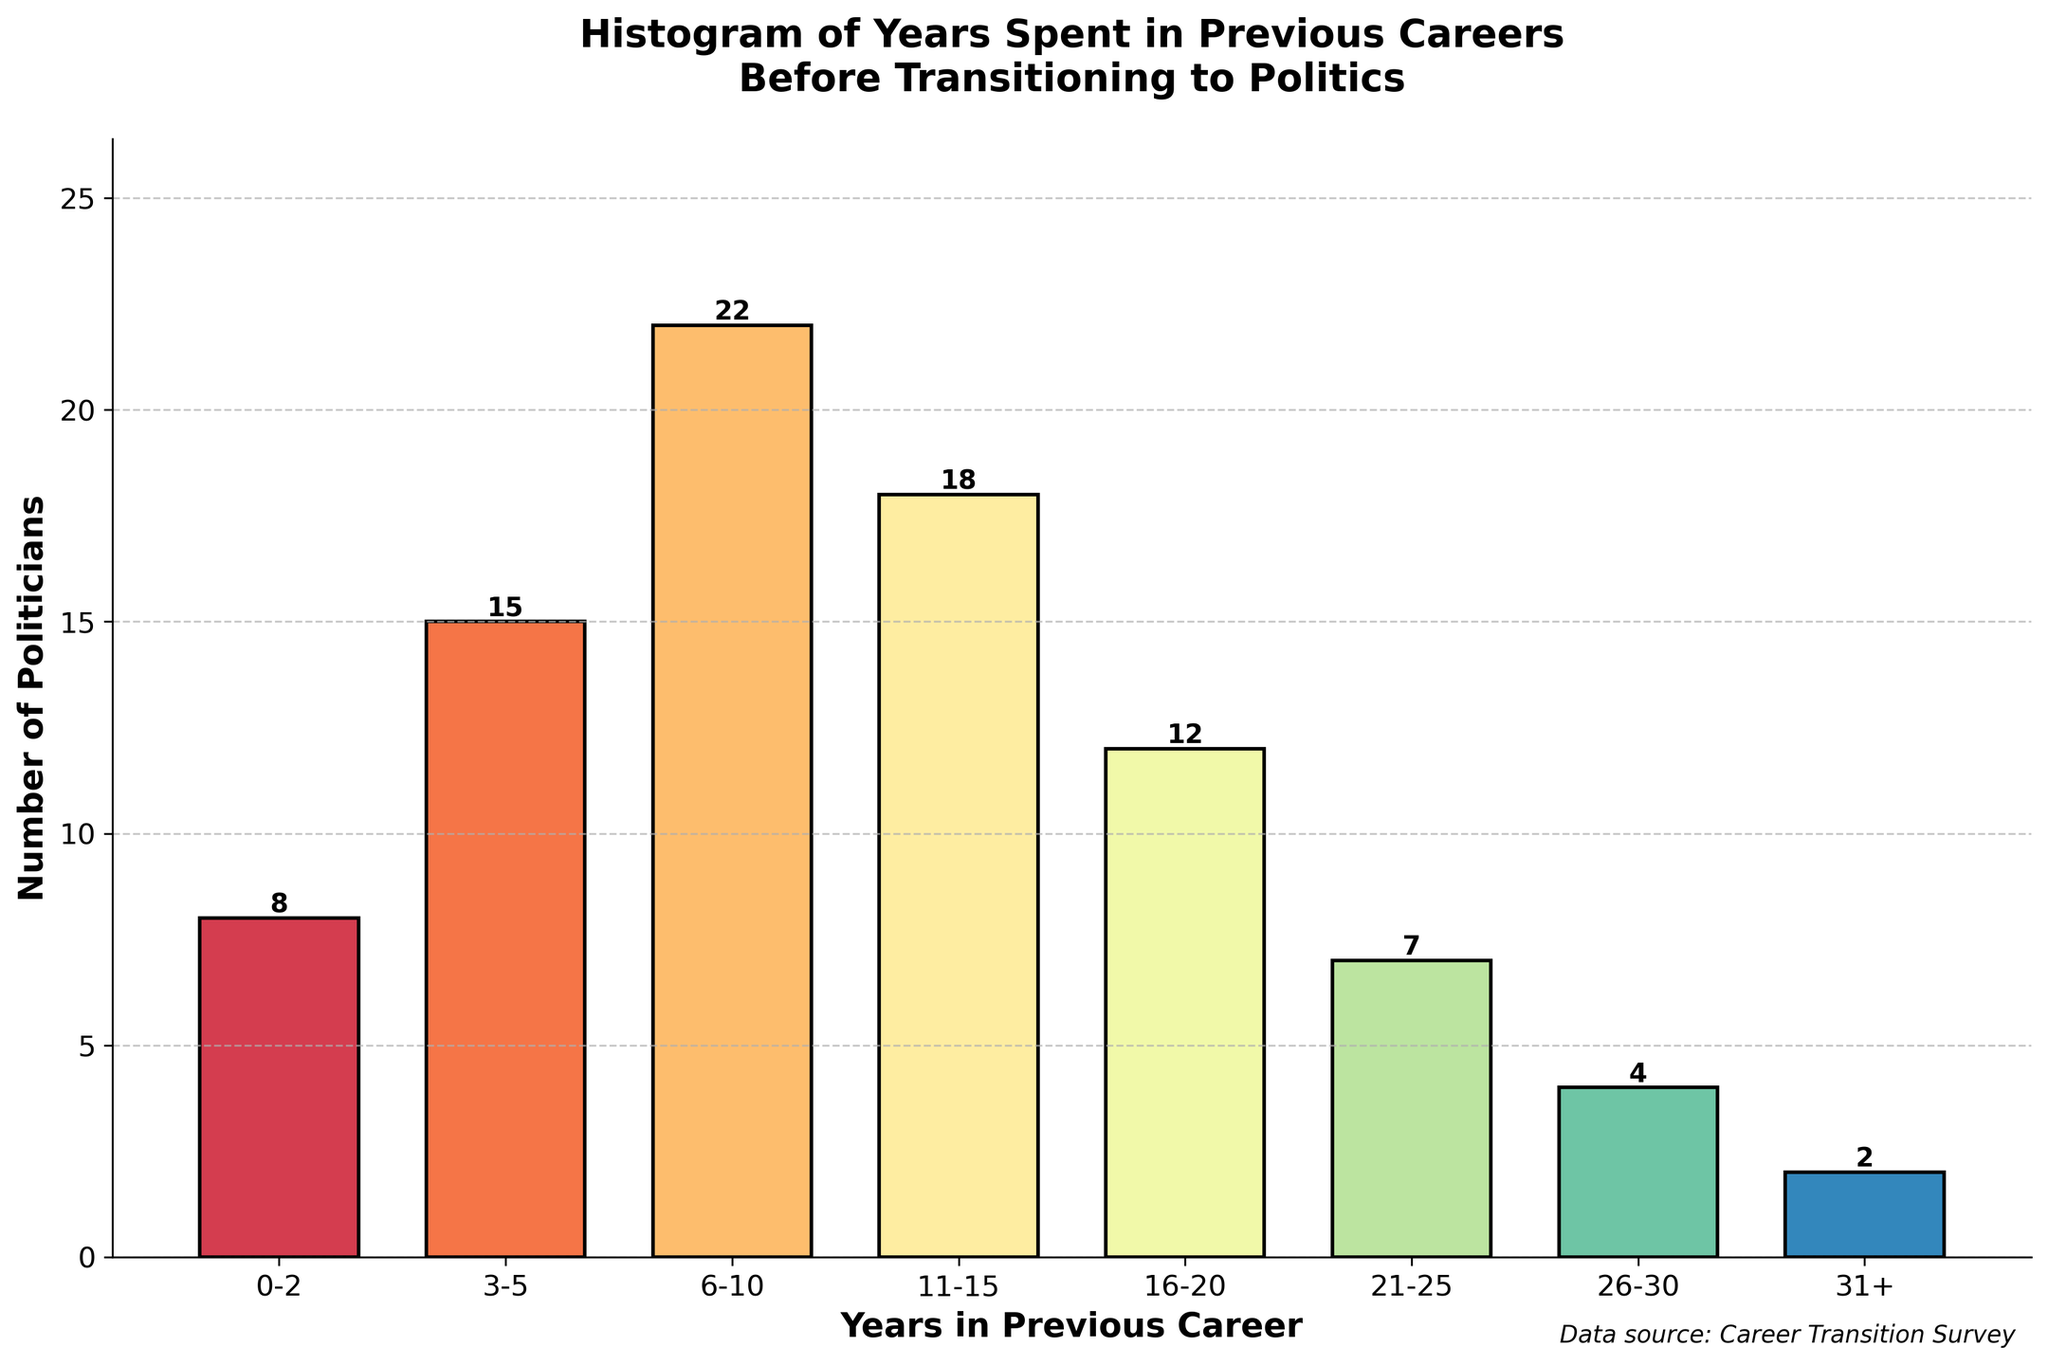What's the title of the histogram? The title of the histogram is typically found at the top of the chart and is meant to provide a summary of what the chart represents. In this case, it's "Histogram of Years Spent in Previous Careers Before Transitioning to Politics."
Answer: Histogram of Years Spent in Previous Careers Before Transitioning to Politics How many politicians spent 16-20 years in their previous careers? To find this, look at the bar corresponding to the "16-20" years category and read off its height. The height of the bar indicates the count.
Answer: 12 Which year range has the highest number of politicians? Examine all the bars and identify the one that is the tallest, as its height will represent the highest count. The tallest bar corresponds to the "6-10" years category with a count of 22.
Answer: 6-10 What is the total number of politicians represented in the histogram? Sum the heights of all the bars to find the total number. The counts are 8 + 15 + 22 + 18 + 12 + 7 + 4 + 2. The total is 88.
Answer: 88 How many more politicians spent 6-10 years in their previous careers compared to those who spent 0-2 years? Determine the counts for both categories ("6-10" has 22 and "0-2" has 8), then subtract the smaller count from the larger one. 22 - 8 = 14.
Answer: 14 What is the median number of years spent in previous careers? To find the median, arrange the categories in order and find the middle value. With 88 total data points, adding the categories from least to most until reaching the midpoint gives us an equal split at the 44th and 45th positions which fall in the "6-10" range. Hence, the median years range is "6-10."
Answer: 6-10 Compare the number of politicians who spent more than 20 years in their previous careers to those who spent less than or equal to 20 years. Sum the counts of categories "21-25," "26-30," and "31+" which total 7 + 4 + 2 = 13. Then sum the counts of all other categories (which total 75). Compare the two sums: 13 politicians spent more than 20 years, and 75 spent 20 years or less.
Answer: More spent 20 years or less If we combined the counts for 0-2 years and 3-5 years, how many politicians would that represent? Add the counts of the "0-2" and "3-5" categories which are 8 and 15, respectively. 8 + 15 = 23.
Answer: 23 What proportion of politicians spent 11-15 years in their previous careers? Divide the count for the "11-15" years category (18) by the total number of politicians (88), then multiply by 100 to get the percentage. (18 / 88) * 100 = 20.45%.
Answer: 20.45% Which category has the fewest politicians? Identify the bar with the smallest height, which corresponds to the "31+" years category with a count of 2.
Answer: 31+ 